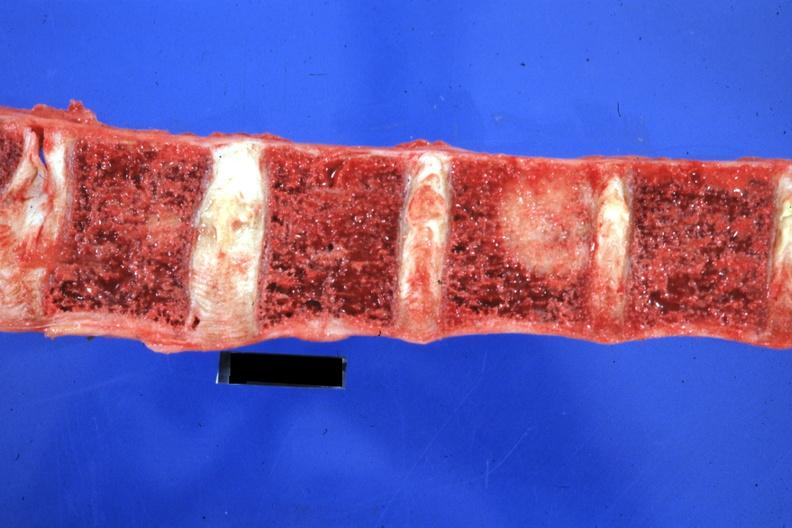does metastatic neuroblastoma show close-up excellent primary tail of pancreas?
Answer the question using a single word or phrase. No 